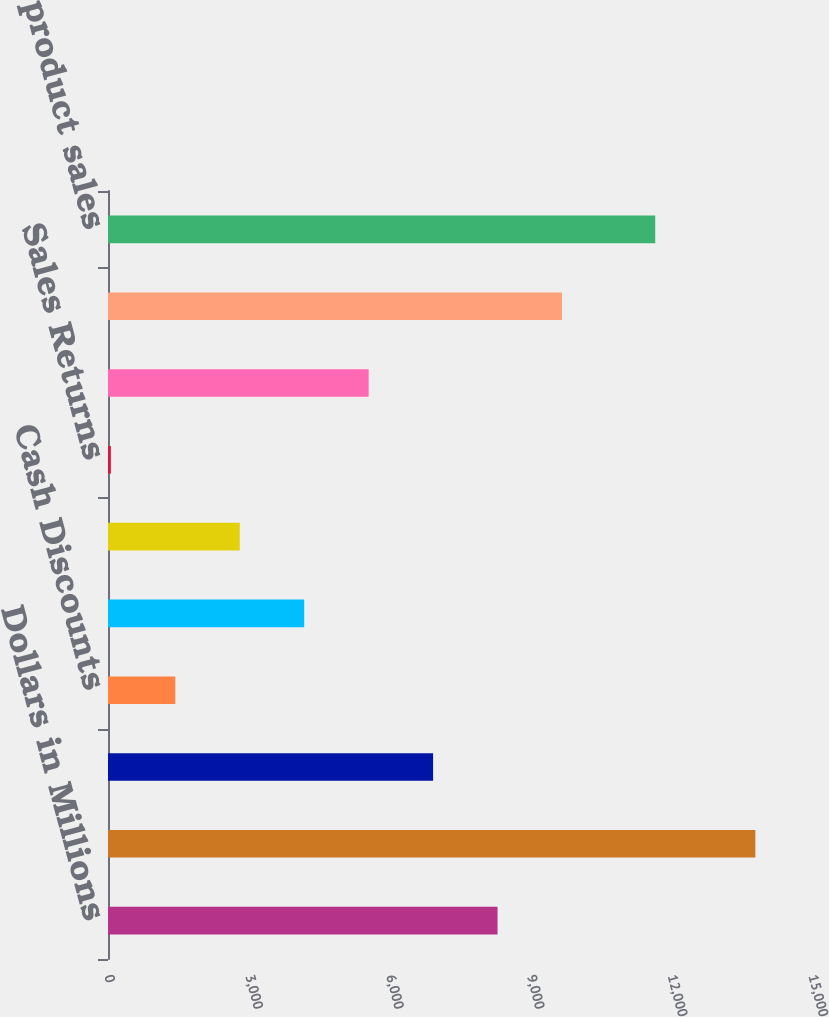Convert chart to OTSL. <chart><loc_0><loc_0><loc_500><loc_500><bar_chart><fcel>Dollars in Millions<fcel>Gross product sales<fcel>Charge-Backs Related to<fcel>Cash Discounts<fcel>Managed Healthcare Rebates and<fcel>Medicaid Rebates<fcel>Sales Returns<fcel>Other Adjustments<fcel>Total Gross-to-Net Adjustments<fcel>Net product sales<nl><fcel>8300.2<fcel>13793<fcel>6927<fcel>1434.2<fcel>4180.6<fcel>2807.4<fcel>61<fcel>5553.8<fcel>9673.4<fcel>11660<nl></chart> 